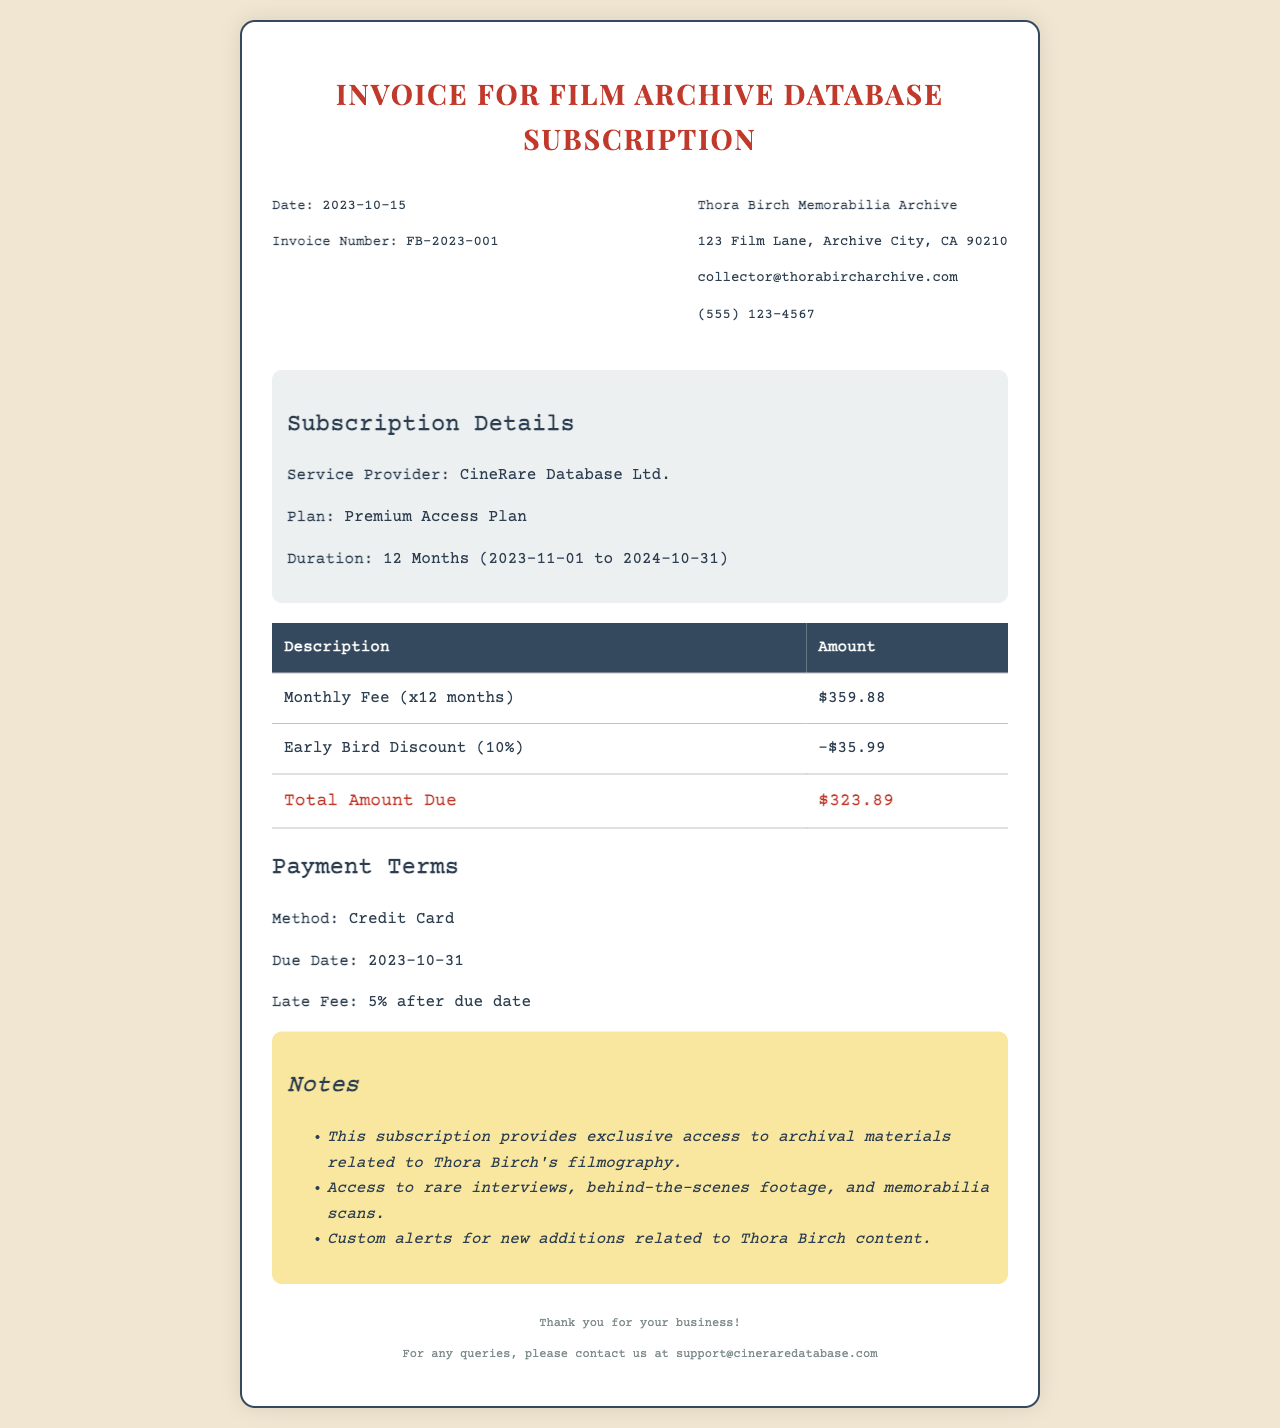What is the invoice number? The invoice number is listed at the top of the document in the header section, specifically labeled as "Invoice Number."
Answer: FB-2023-001 What is the service duration? The service duration is mentioned in the subscription details section under "Duration," specifying the start and end date of the subscription.
Answer: 12 Months (2023-11-01 to 2024-10-31) What is the total amount due? The total amount due is found at the end of the fees table, specifically in the last row labeled "Total Amount Due."
Answer: $323.89 What is the early bird discount percentage? The discount offered is stated in the fees table and is labeled as the "Early Bird Discount."
Answer: 10% What is the due date for the payment? The due date for the payment is mentioned in the payment terms section under "Due Date."
Answer: 2023-10-31 What method of payment is accepted? The payment method is specified in the payment terms section, indicating how the payment can be made.
Answer: Credit Card What kind of access does the subscription provide? The notes section provides a brief overview of the type of access included in the subscription, focusing on the materials available.
Answer: Exclusive access to archival materials What is the late fee percentage? The late fee percentage is provided in the payment terms section next to the "Late Fee" label, indicating the additional charge for late payments.
Answer: 5% 